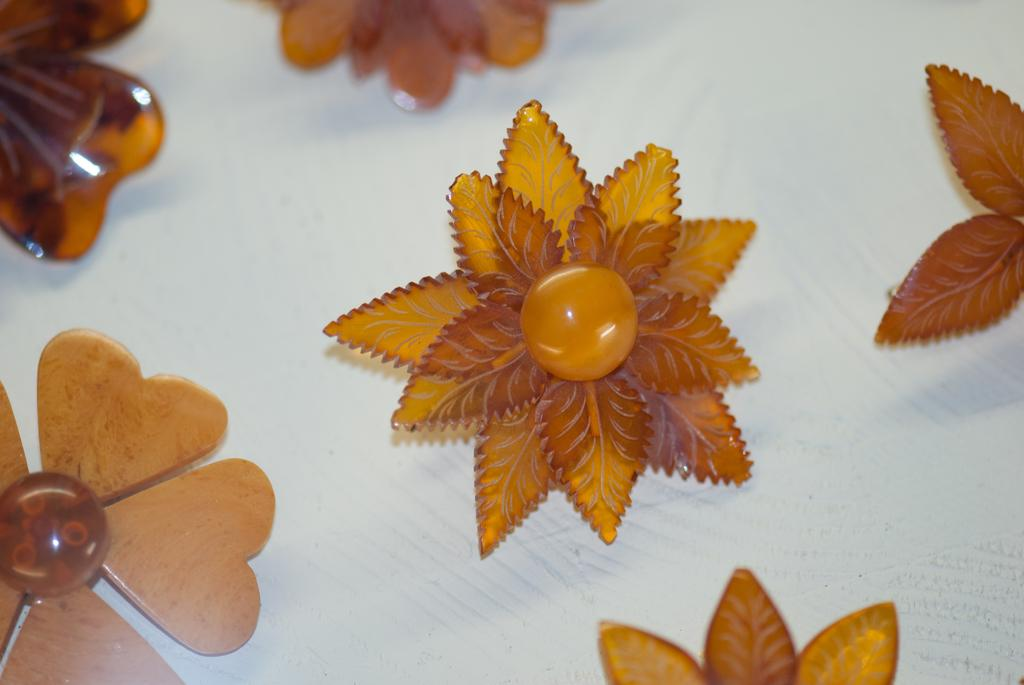What is the primary color of the surface in the image? The primary color of the surface in the image is white. What type of objects are placed on the white surface? There are brown-colored artificial flowers on the white surface. What type of board game is being played on the white surface in the image? There is no board game present in the image; it features a white surface with brown-colored artificial flowers. 